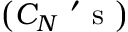<formula> <loc_0><loc_0><loc_500><loc_500>\left ( C _ { N } ^ { \prime } s \right )</formula> 